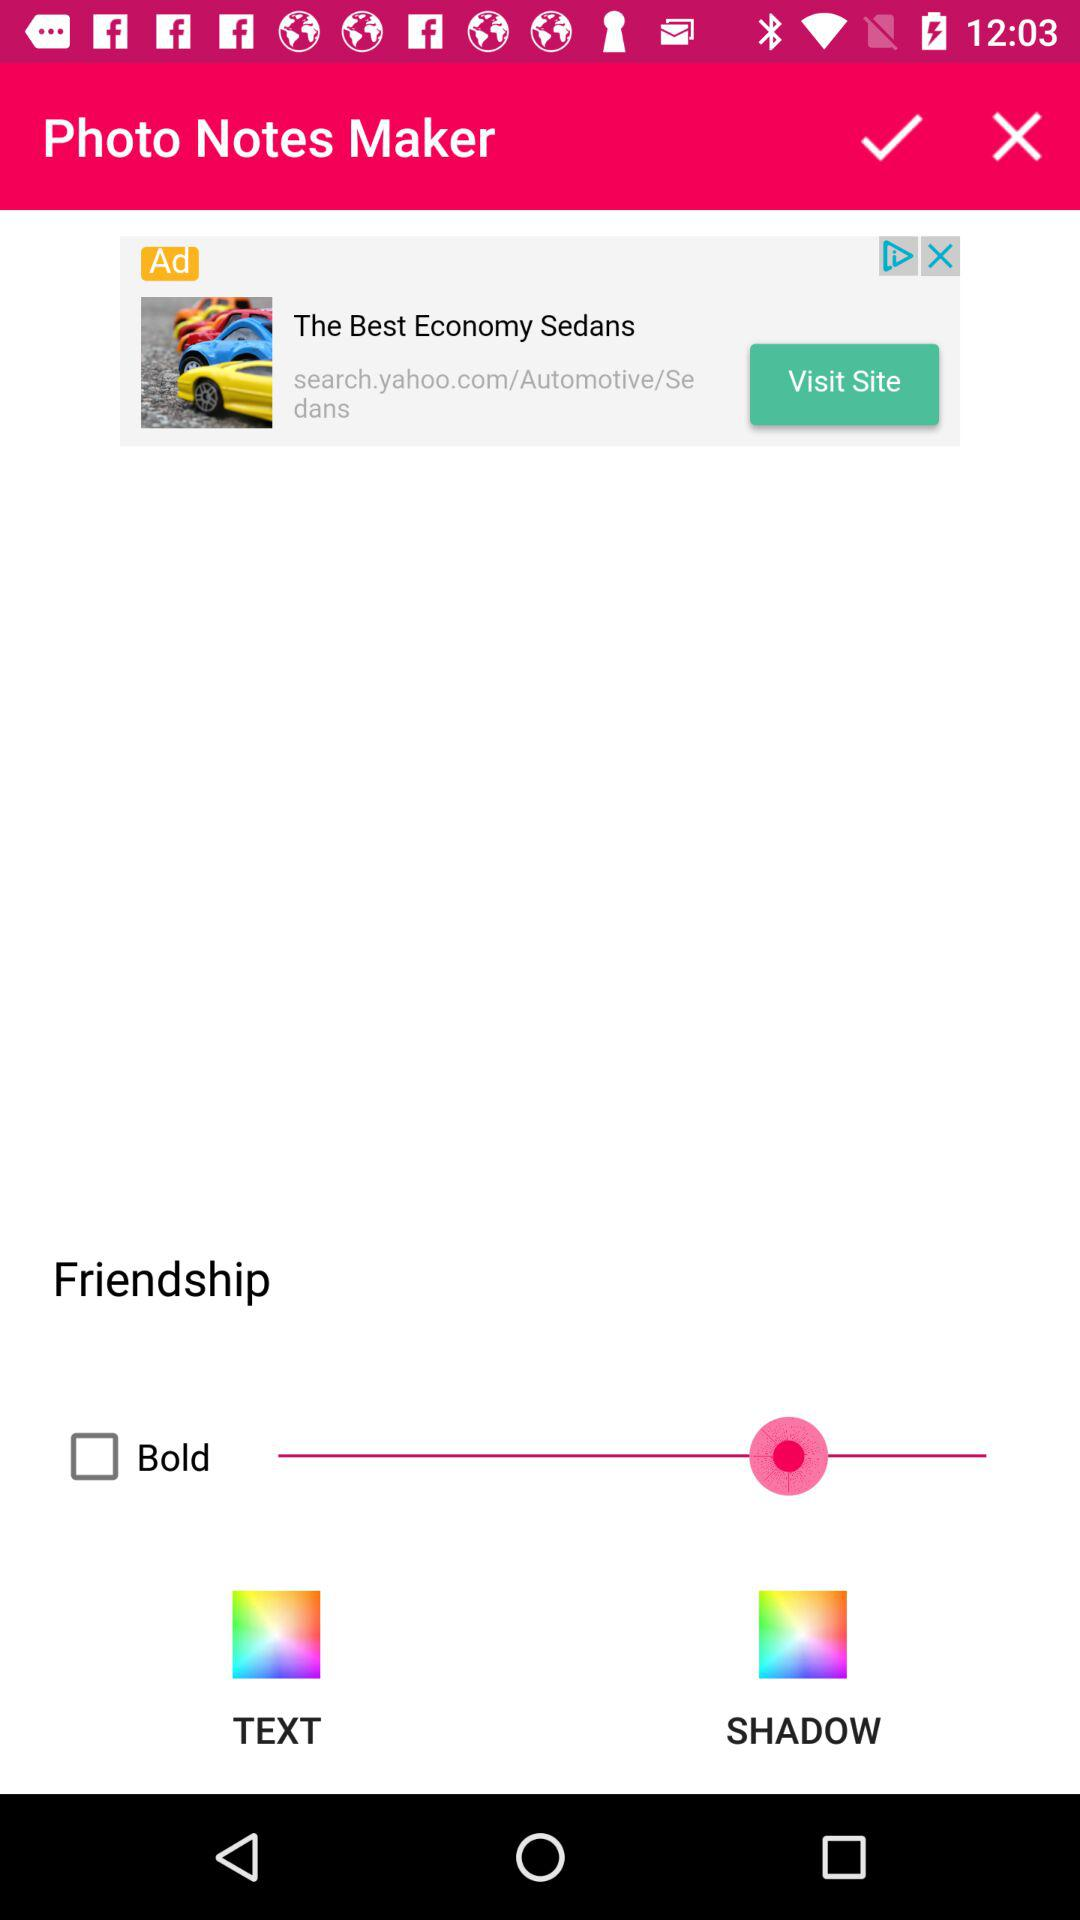What is the status of "Bold"? The status is "off". 